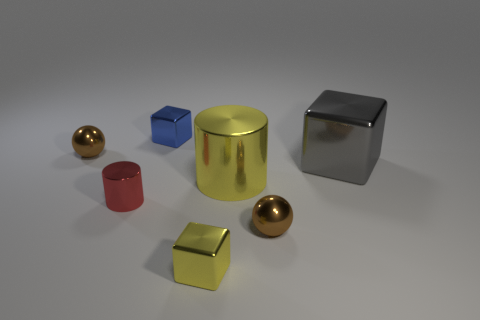Is there a large blue cylinder?
Ensure brevity in your answer.  No. Do the yellow object that is behind the tiny cylinder and the small brown ball that is behind the big metallic cylinder have the same material?
Ensure brevity in your answer.  Yes. There is a shiny block that is behind the brown ball on the left side of the tiny cube behind the yellow block; what size is it?
Offer a very short reply. Small. What number of brown spheres are the same material as the big gray object?
Your answer should be very brief. 2. Are there fewer metallic spheres than tiny gray objects?
Your answer should be very brief. No. There is a yellow thing that is the same shape as the small blue metallic thing; what is its size?
Provide a short and direct response. Small. Is the material of the sphere that is to the right of the big yellow shiny object the same as the red thing?
Give a very brief answer. Yes. Is the big gray thing the same shape as the blue thing?
Your answer should be very brief. Yes. What number of things are either brown spheres that are on the right side of the tiny red thing or metal things?
Your response must be concise. 7. There is another cylinder that is the same material as the big cylinder; what size is it?
Your answer should be compact. Small. 